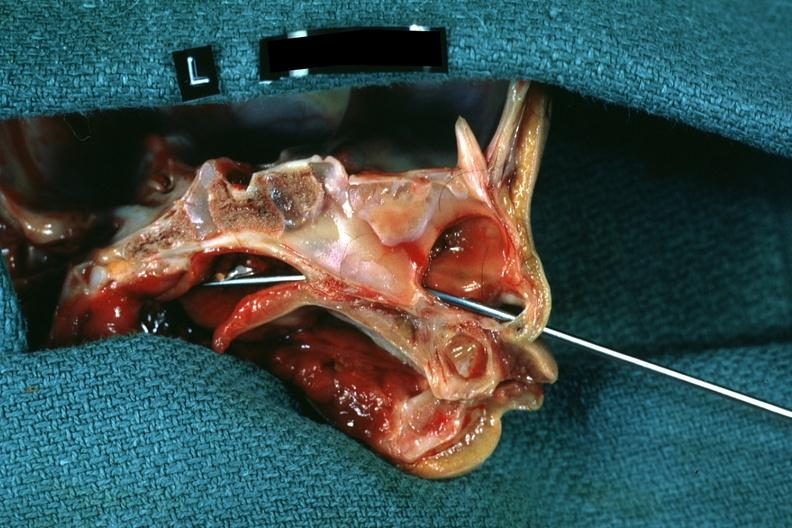what was not patent?
Answer the question using a single word or phrase. Side showing patency right side 